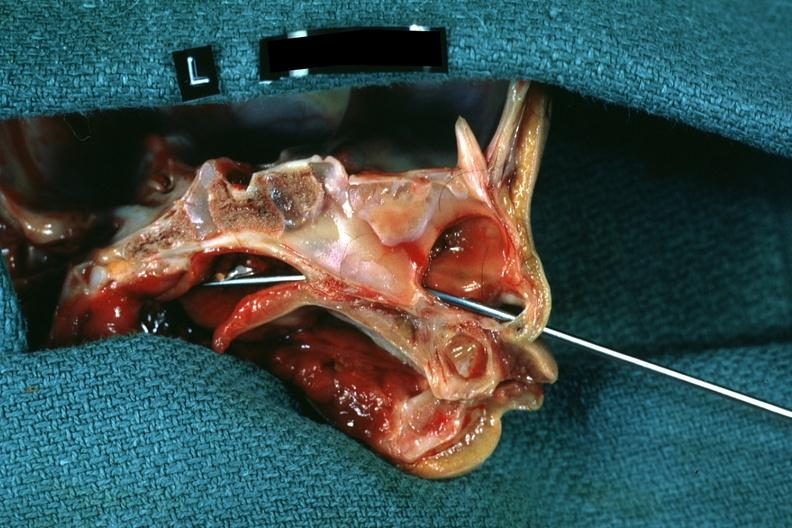what was not patent?
Answer the question using a single word or phrase. Side showing patency right side 